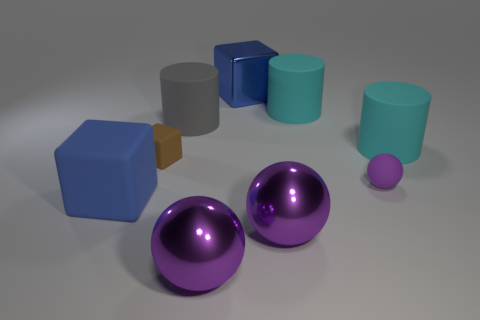Subtract all tiny balls. How many balls are left? 2 Subtract 2 cubes. How many cubes are left? 1 Subtract all purple cubes. How many cyan cylinders are left? 2 Subtract all blue blocks. How many blocks are left? 1 Subtract all purple blocks. Subtract all brown balls. How many blocks are left? 3 Subtract all cylinders. How many objects are left? 6 Subtract all large red metal objects. Subtract all metal cubes. How many objects are left? 8 Add 4 big gray rubber cylinders. How many big gray rubber cylinders are left? 5 Add 8 brown cubes. How many brown cubes exist? 9 Subtract 0 cyan cubes. How many objects are left? 9 